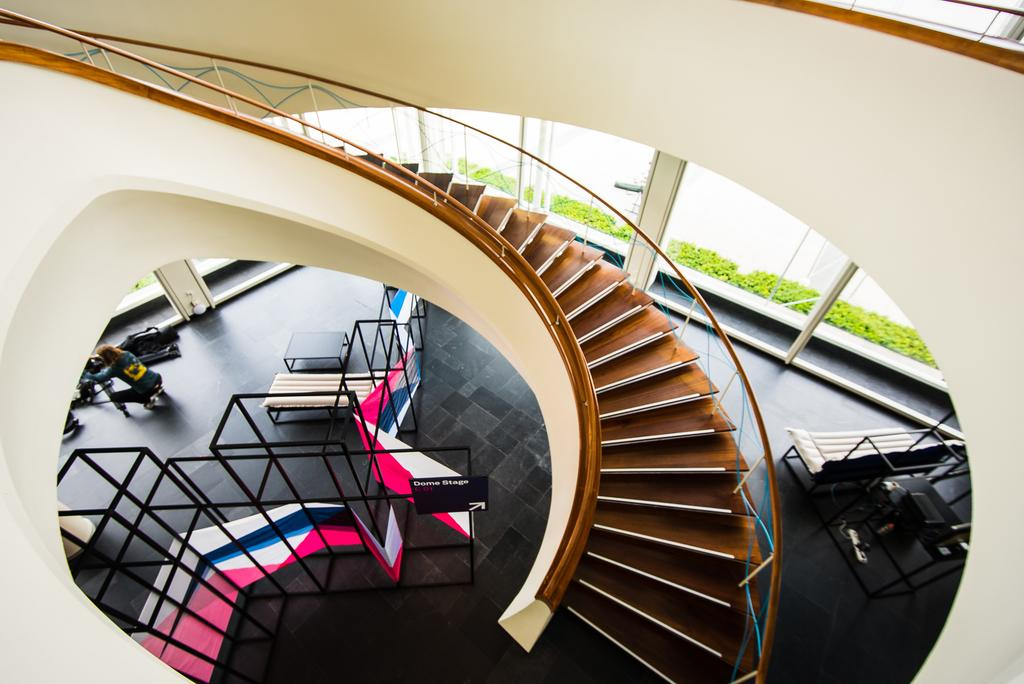What type of location is depicted in the image? A: The image is an inside view of a building. What architectural feature can be seen in the image? There are stairs in the image. What material is used for the rods in the image? Iron rods are present in the image. What object is used for displaying information or announcements? There is a board in the image. What type of vegetation is visible in the image? Plants are visible in the image. Can you describe the person in the image? There is a person in the image. What other items can be seen in the image besides the ones mentioned? There are other items in the image. What time of day is it in the image? The provided facts do not mention the time of day, so it cannot be determined from the image. 